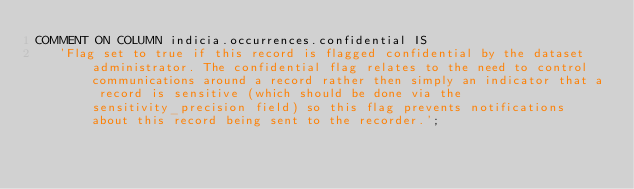<code> <loc_0><loc_0><loc_500><loc_500><_SQL_>COMMENT ON COLUMN indicia.occurrences.confidential IS
   'Flag set to true if this record is flagged confidential by the dataset administrator. The confidential flag relates to the need to control communications around a record rather then simply an indicator that a record is sensitive (which should be done via the sensitivity_precision field) so this flag prevents notifications about this record being sent to the recorder.';
</code> 